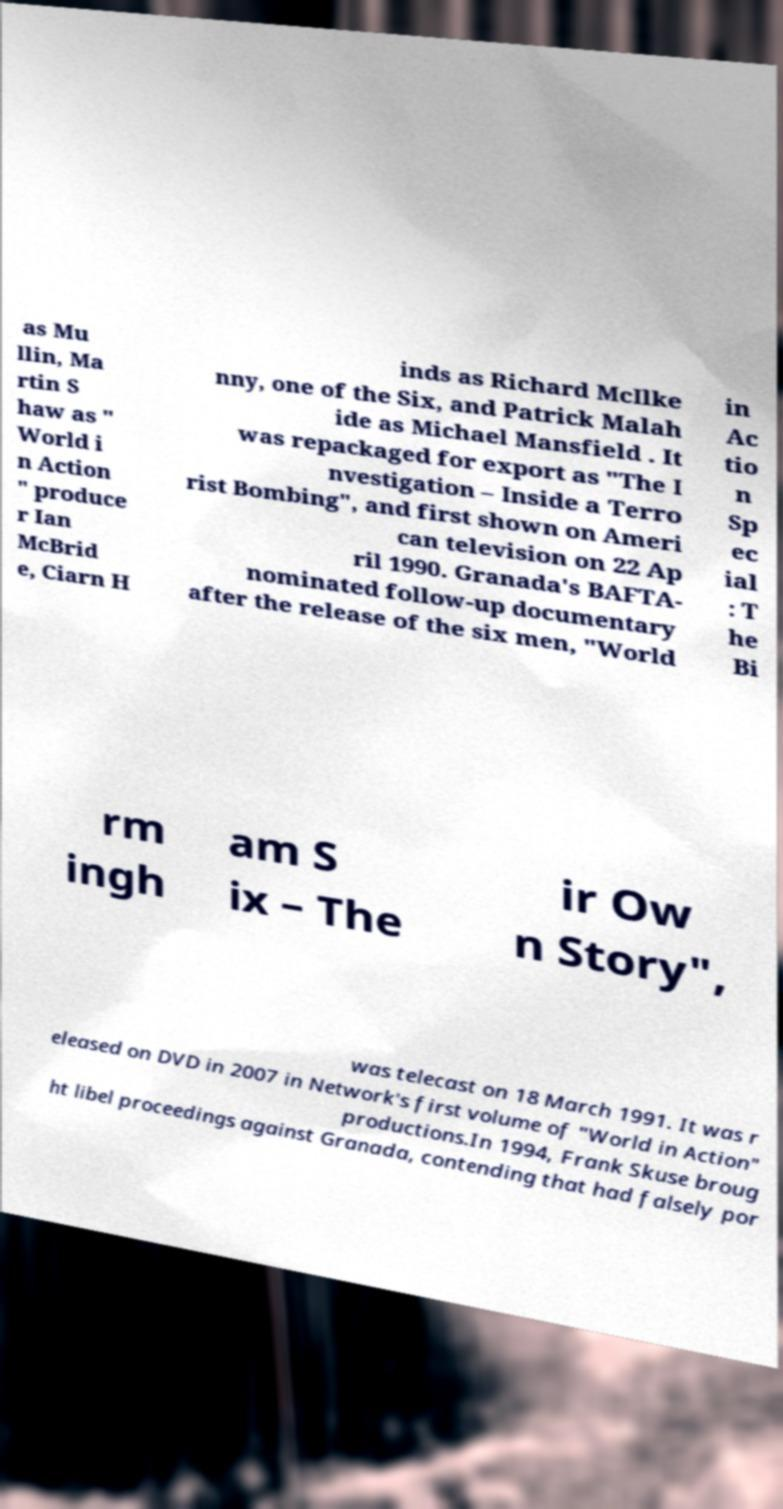Could you extract and type out the text from this image? as Mu llin, Ma rtin S haw as " World i n Action " produce r Ian McBrid e, Ciarn H inds as Richard McIlke nny, one of the Six, and Patrick Malah ide as Michael Mansfield . It was repackaged for export as "The I nvestigation – Inside a Terro rist Bombing", and first shown on Ameri can television on 22 Ap ril 1990. Granada's BAFTA- nominated follow-up documentary after the release of the six men, "World in Ac tio n Sp ec ial : T he Bi rm ingh am S ix – The ir Ow n Story", was telecast on 18 March 1991. It was r eleased on DVD in 2007 in Network's first volume of "World in Action" productions.In 1994, Frank Skuse broug ht libel proceedings against Granada, contending that had falsely por 